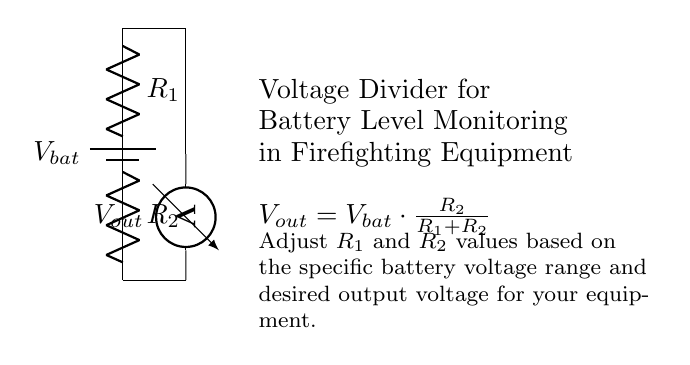What is the type of circuit depicted? The circuit is a voltage divider, which consists of two resistors arranged in series that divides the input voltage into a lower output voltage based on the resistor values.
Answer: Voltage divider What does the voltmeter measure? The voltmeter measures the output voltage across resistor R2, which represents the voltage level of the battery after it has been divided by R1 and R2.
Answer: Output voltage What is the equation for Vout in this circuit? The equation provided in the circuit diagram shows that Vout is calculated by multiplying the battery voltage by the fraction of R2 over the total resistance (R1 + R2), reflecting how the two resistors divide the voltage.
Answer: Vout = Vbat * (R2 / (R1 + R2)) How can R1 and R2 be adjusted? The note states that R1 and R2 should be adjusted based on the specific battery voltage range and desired output voltage for the equipment, implying one can choose resistor values for desired voltage division.
Answer: Based on battery voltage and desired output What is the purpose of this voltage divider circuit? The purpose is to monitor the battery voltage of firefighting equipment, allowing for indications of battery levels to ensure functionality and safety.
Answer: Battery level monitoring Which component provides the input voltage? The input voltage is supplied by the battery, represented as Vbat in the circuit, indicating the source of electrical power for this voltage divider setup.
Answer: Battery 